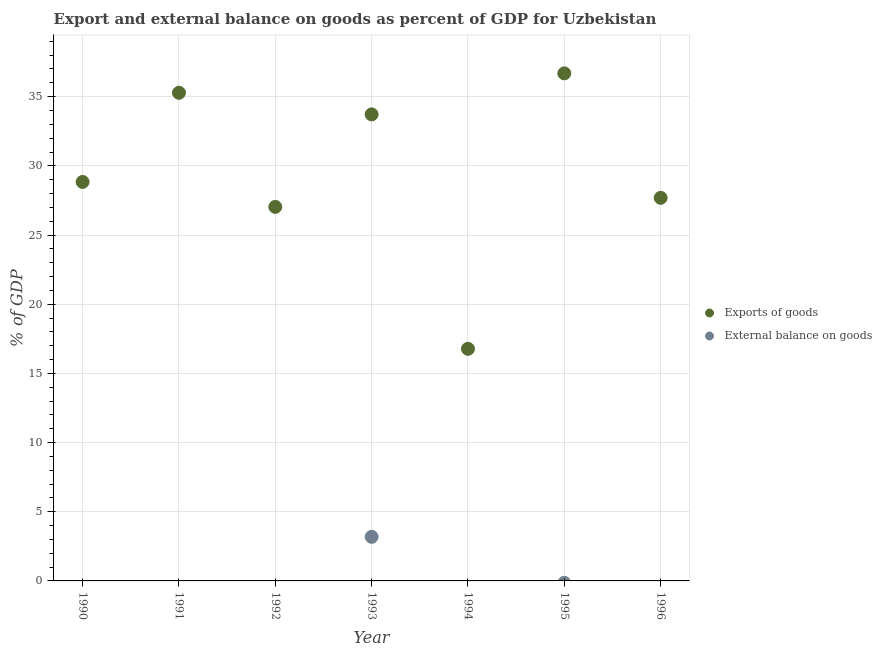Is the number of dotlines equal to the number of legend labels?
Your response must be concise. No. What is the export of goods as percentage of gdp in 1996?
Keep it short and to the point. 27.69. Across all years, what is the maximum external balance on goods as percentage of gdp?
Offer a terse response. 3.19. Across all years, what is the minimum external balance on goods as percentage of gdp?
Offer a very short reply. 0. In which year was the export of goods as percentage of gdp maximum?
Provide a succinct answer. 1995. What is the total export of goods as percentage of gdp in the graph?
Your response must be concise. 206.02. What is the difference between the export of goods as percentage of gdp in 1994 and that in 1996?
Keep it short and to the point. -10.91. What is the difference between the export of goods as percentage of gdp in 1996 and the external balance on goods as percentage of gdp in 1995?
Your answer should be compact. 27.69. What is the average external balance on goods as percentage of gdp per year?
Provide a short and direct response. 0.46. In the year 1993, what is the difference between the export of goods as percentage of gdp and external balance on goods as percentage of gdp?
Ensure brevity in your answer.  30.53. In how many years, is the external balance on goods as percentage of gdp greater than 3 %?
Give a very brief answer. 1. What is the ratio of the export of goods as percentage of gdp in 1990 to that in 1994?
Your response must be concise. 1.72. What is the difference between the highest and the second highest export of goods as percentage of gdp?
Offer a very short reply. 1.4. What is the difference between the highest and the lowest external balance on goods as percentage of gdp?
Your answer should be compact. 3.19. In how many years, is the external balance on goods as percentage of gdp greater than the average external balance on goods as percentage of gdp taken over all years?
Offer a terse response. 1. Does the external balance on goods as percentage of gdp monotonically increase over the years?
Offer a very short reply. No. How many dotlines are there?
Provide a succinct answer. 2. Does the graph contain any zero values?
Your response must be concise. Yes. Does the graph contain grids?
Your response must be concise. Yes. How many legend labels are there?
Offer a very short reply. 2. How are the legend labels stacked?
Provide a succinct answer. Vertical. What is the title of the graph?
Your answer should be very brief. Export and external balance on goods as percent of GDP for Uzbekistan. What is the label or title of the Y-axis?
Offer a very short reply. % of GDP. What is the % of GDP in Exports of goods in 1990?
Keep it short and to the point. 28.84. What is the % of GDP in Exports of goods in 1991?
Offer a very short reply. 35.28. What is the % of GDP in Exports of goods in 1992?
Make the answer very short. 27.03. What is the % of GDP in Exports of goods in 1993?
Your answer should be very brief. 33.72. What is the % of GDP in External balance on goods in 1993?
Your response must be concise. 3.19. What is the % of GDP in Exports of goods in 1994?
Offer a very short reply. 16.78. What is the % of GDP of External balance on goods in 1994?
Offer a terse response. 0. What is the % of GDP of Exports of goods in 1995?
Offer a very short reply. 36.68. What is the % of GDP of External balance on goods in 1995?
Your answer should be very brief. 0. What is the % of GDP of Exports of goods in 1996?
Offer a terse response. 27.69. What is the % of GDP in External balance on goods in 1996?
Ensure brevity in your answer.  0. Across all years, what is the maximum % of GDP of Exports of goods?
Ensure brevity in your answer.  36.68. Across all years, what is the maximum % of GDP of External balance on goods?
Your answer should be compact. 3.19. Across all years, what is the minimum % of GDP of Exports of goods?
Offer a terse response. 16.78. What is the total % of GDP of Exports of goods in the graph?
Make the answer very short. 206.02. What is the total % of GDP of External balance on goods in the graph?
Provide a succinct answer. 3.19. What is the difference between the % of GDP in Exports of goods in 1990 and that in 1991?
Your answer should be compact. -6.44. What is the difference between the % of GDP in Exports of goods in 1990 and that in 1992?
Give a very brief answer. 1.8. What is the difference between the % of GDP of Exports of goods in 1990 and that in 1993?
Give a very brief answer. -4.88. What is the difference between the % of GDP of Exports of goods in 1990 and that in 1994?
Give a very brief answer. 12.06. What is the difference between the % of GDP in Exports of goods in 1990 and that in 1995?
Provide a short and direct response. -7.85. What is the difference between the % of GDP of Exports of goods in 1990 and that in 1996?
Your answer should be very brief. 1.15. What is the difference between the % of GDP in Exports of goods in 1991 and that in 1992?
Keep it short and to the point. 8.25. What is the difference between the % of GDP of Exports of goods in 1991 and that in 1993?
Keep it short and to the point. 1.56. What is the difference between the % of GDP of Exports of goods in 1991 and that in 1994?
Offer a terse response. 18.5. What is the difference between the % of GDP in Exports of goods in 1991 and that in 1995?
Make the answer very short. -1.4. What is the difference between the % of GDP of Exports of goods in 1991 and that in 1996?
Make the answer very short. 7.59. What is the difference between the % of GDP of Exports of goods in 1992 and that in 1993?
Offer a terse response. -6.69. What is the difference between the % of GDP of Exports of goods in 1992 and that in 1994?
Make the answer very short. 10.26. What is the difference between the % of GDP in Exports of goods in 1992 and that in 1995?
Your response must be concise. -9.65. What is the difference between the % of GDP of Exports of goods in 1992 and that in 1996?
Offer a very short reply. -0.65. What is the difference between the % of GDP of Exports of goods in 1993 and that in 1994?
Ensure brevity in your answer.  16.94. What is the difference between the % of GDP of Exports of goods in 1993 and that in 1995?
Your answer should be very brief. -2.96. What is the difference between the % of GDP in Exports of goods in 1993 and that in 1996?
Provide a succinct answer. 6.03. What is the difference between the % of GDP of Exports of goods in 1994 and that in 1995?
Provide a short and direct response. -19.91. What is the difference between the % of GDP in Exports of goods in 1994 and that in 1996?
Keep it short and to the point. -10.91. What is the difference between the % of GDP in Exports of goods in 1995 and that in 1996?
Provide a short and direct response. 9. What is the difference between the % of GDP of Exports of goods in 1990 and the % of GDP of External balance on goods in 1993?
Offer a terse response. 25.65. What is the difference between the % of GDP in Exports of goods in 1991 and the % of GDP in External balance on goods in 1993?
Offer a very short reply. 32.09. What is the difference between the % of GDP in Exports of goods in 1992 and the % of GDP in External balance on goods in 1993?
Your answer should be compact. 23.85. What is the average % of GDP in Exports of goods per year?
Provide a short and direct response. 29.43. What is the average % of GDP in External balance on goods per year?
Ensure brevity in your answer.  0.46. In the year 1993, what is the difference between the % of GDP in Exports of goods and % of GDP in External balance on goods?
Provide a short and direct response. 30.53. What is the ratio of the % of GDP of Exports of goods in 1990 to that in 1991?
Ensure brevity in your answer.  0.82. What is the ratio of the % of GDP of Exports of goods in 1990 to that in 1992?
Your answer should be compact. 1.07. What is the ratio of the % of GDP of Exports of goods in 1990 to that in 1993?
Your answer should be very brief. 0.86. What is the ratio of the % of GDP in Exports of goods in 1990 to that in 1994?
Offer a terse response. 1.72. What is the ratio of the % of GDP in Exports of goods in 1990 to that in 1995?
Keep it short and to the point. 0.79. What is the ratio of the % of GDP in Exports of goods in 1990 to that in 1996?
Your response must be concise. 1.04. What is the ratio of the % of GDP in Exports of goods in 1991 to that in 1992?
Make the answer very short. 1.3. What is the ratio of the % of GDP of Exports of goods in 1991 to that in 1993?
Give a very brief answer. 1.05. What is the ratio of the % of GDP of Exports of goods in 1991 to that in 1994?
Offer a terse response. 2.1. What is the ratio of the % of GDP in Exports of goods in 1991 to that in 1995?
Provide a short and direct response. 0.96. What is the ratio of the % of GDP in Exports of goods in 1991 to that in 1996?
Offer a very short reply. 1.27. What is the ratio of the % of GDP of Exports of goods in 1992 to that in 1993?
Your answer should be very brief. 0.8. What is the ratio of the % of GDP of Exports of goods in 1992 to that in 1994?
Your answer should be compact. 1.61. What is the ratio of the % of GDP of Exports of goods in 1992 to that in 1995?
Your answer should be very brief. 0.74. What is the ratio of the % of GDP in Exports of goods in 1992 to that in 1996?
Offer a very short reply. 0.98. What is the ratio of the % of GDP in Exports of goods in 1993 to that in 1994?
Your answer should be very brief. 2.01. What is the ratio of the % of GDP of Exports of goods in 1993 to that in 1995?
Give a very brief answer. 0.92. What is the ratio of the % of GDP in Exports of goods in 1993 to that in 1996?
Your answer should be compact. 1.22. What is the ratio of the % of GDP in Exports of goods in 1994 to that in 1995?
Provide a short and direct response. 0.46. What is the ratio of the % of GDP of Exports of goods in 1994 to that in 1996?
Ensure brevity in your answer.  0.61. What is the ratio of the % of GDP in Exports of goods in 1995 to that in 1996?
Your answer should be compact. 1.32. What is the difference between the highest and the second highest % of GDP in Exports of goods?
Offer a very short reply. 1.4. What is the difference between the highest and the lowest % of GDP in Exports of goods?
Provide a short and direct response. 19.91. What is the difference between the highest and the lowest % of GDP in External balance on goods?
Keep it short and to the point. 3.19. 